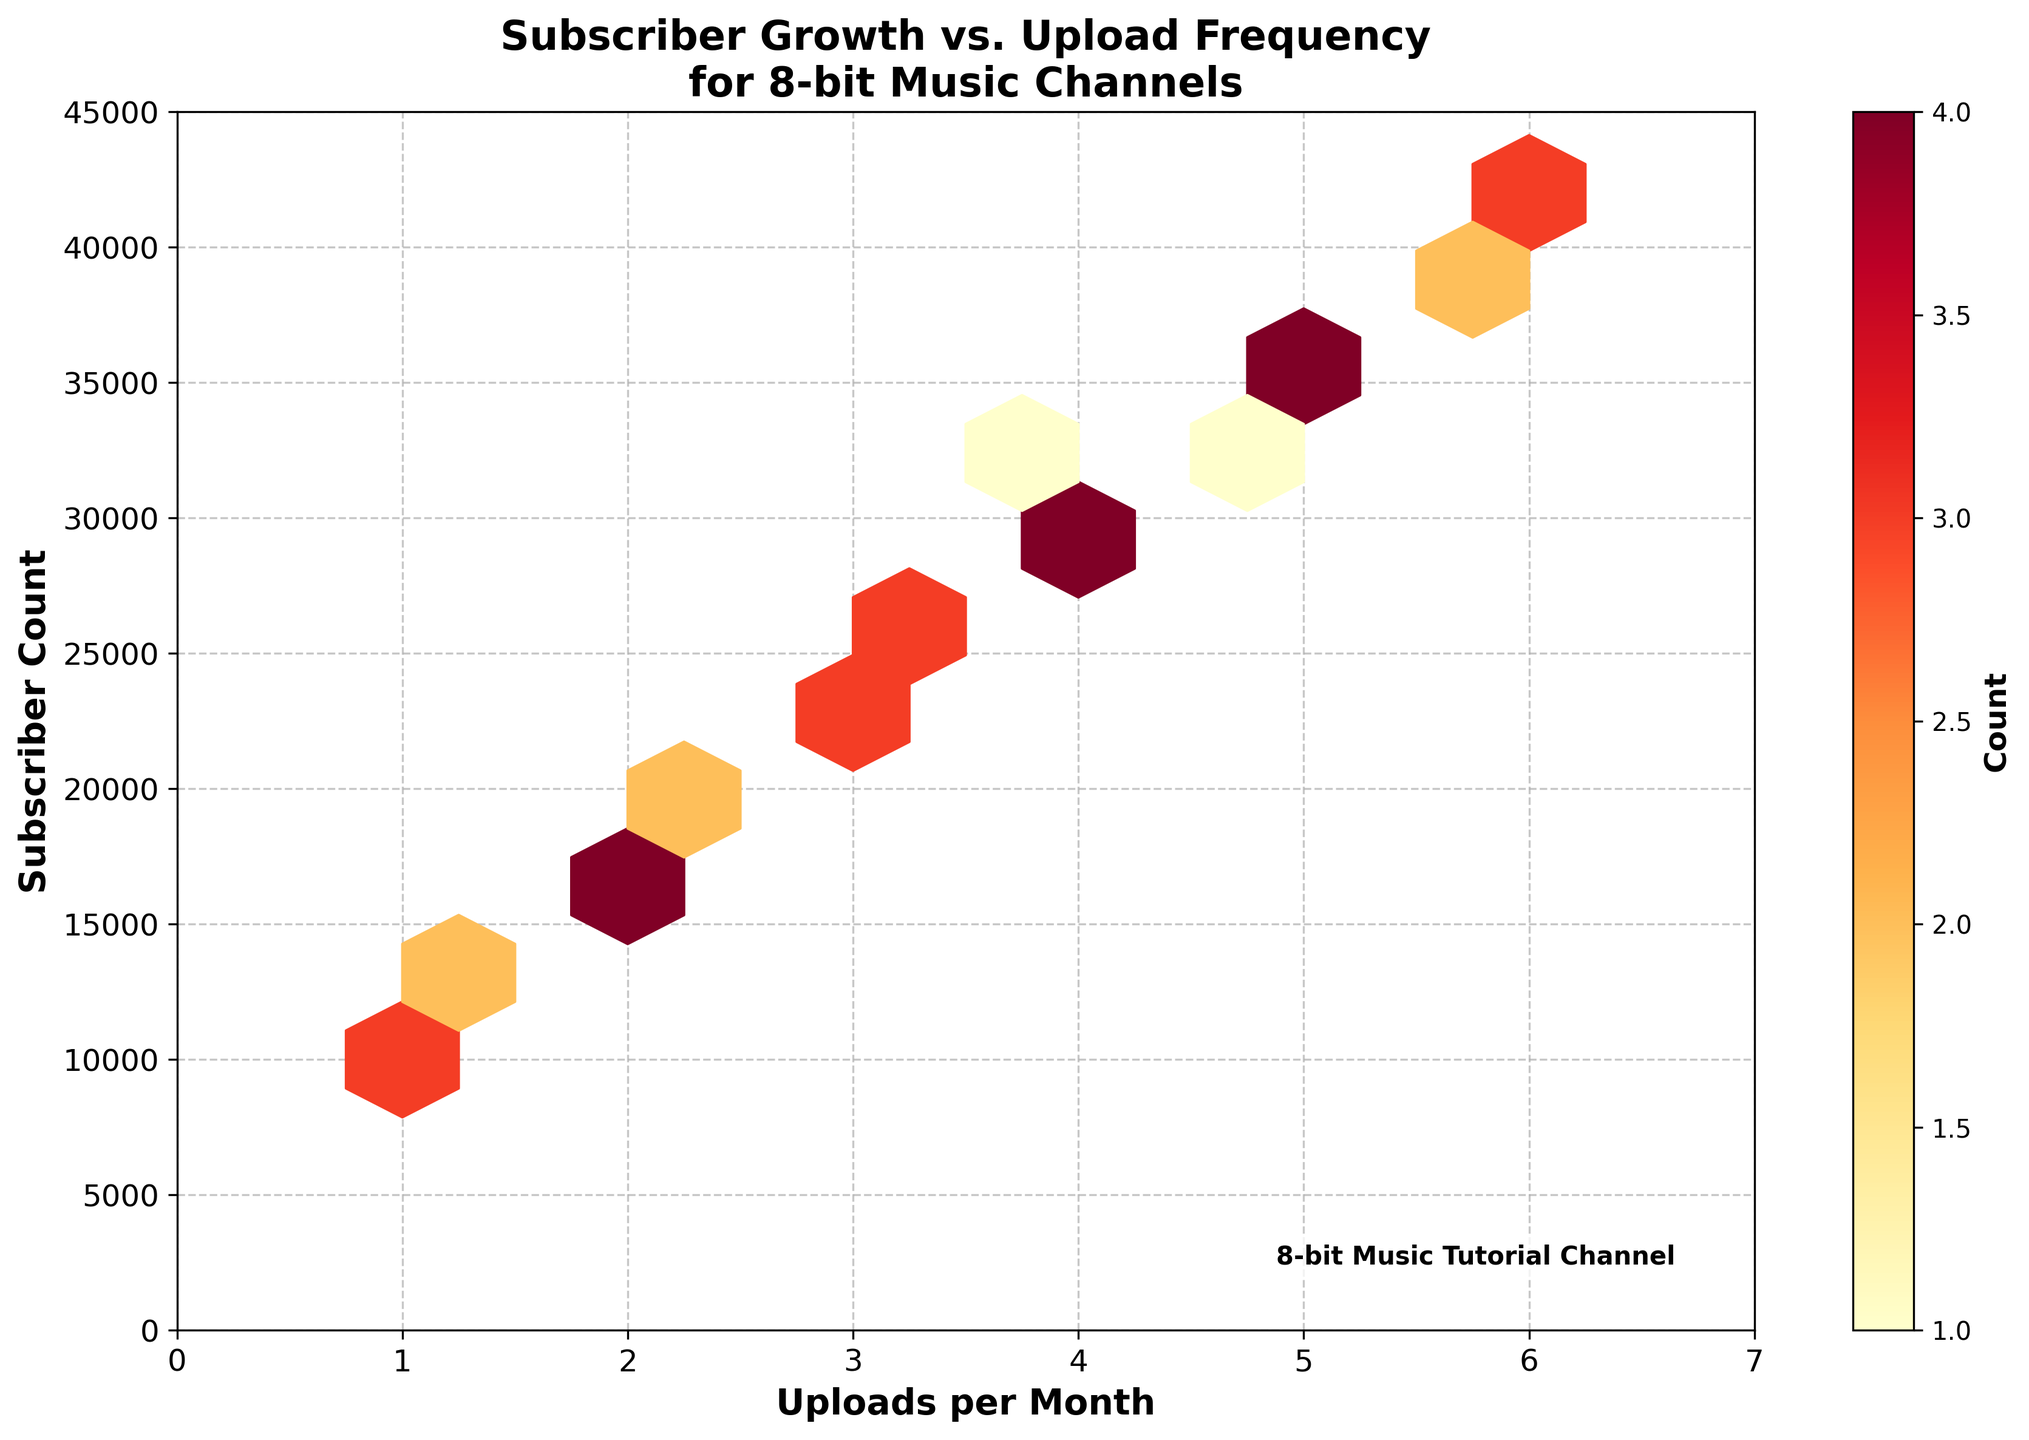What is the title of the plot? The title of the plot is presented at the top, describing what the figure represents: 'Subscriber Growth vs. Upload Frequency for 8-bit Music Channels'.
Answer: Subscriber Growth vs. Upload Frequency for 8-bit Music Channels What are the variables on the x-axis and y-axis? The x-axis and y-axis labels are shown near the axes. The x-axis is labeled 'Uploads per Month', and the y-axis is labeled 'Subscriber Count'.
Answer: Uploads per Month; Subscriber Count How many color bins are there in the hexbin plot? The figure uses different shades of yellow, orange, and red to show density. By observing the color legend, there are three major color bins: yellow, orange, and red. However, exact colors within these ranges might vary, making it difficult to count precisely, but the main groups can be visually identified.
Answer: 3 main color bins Which upload frequency range has the highest concentration of higher subscriber count (darker colored hexagons)? The darkest colored hexagons, which indicate the highest concentration of data points, are located in the upload frequency range of 5 to 6 uploads per month. These are in the top right section of the plot.
Answer: 5 to 6 uploads per month What is the approximate range of subscriber counts for channels that upload 3 times per month? By looking at the vertical range of hexagons aligned with '3' on the x-axis, the subscriber counts appear to range approximately from 20,000 to 27,000.
Answer: 20,000 to 27,000 Is there a positive or negative correlation between uploads per month and subscriber count? Observing the hexbin pattern trending from lower left (fewer uploads and lower subscriber count) to upper right (more uploads and higher subscriber count) suggests a positive correlation.
Answer: Positive correlation What does the color bar represent in the plot? The color bar on the side of the plot indicates the count of data points in each hexbin. Darker colors correspond to higher counts.
Answer: Count of data points Which upload frequency ranges show the least number of data points (lightest colored hexagons)? The lightest hexagons, which indicate the least number of data points, are found at the ends of the x-axis (1 upload per month and 6 uploads per month range).
Answer: 1 and 6 uploads per month Approximately how many data points fall into the hexbin with the highest concentration (darkest color)? The color bar indicates that the count for the darkest hexagons is around 3 to possibly a few more. The exact count is given on the bar itself, corresponding to the darkest color on the plot.
Answer: Around 3 Do channels that upload only once a month achieve high subscriber counts? Observing the leftmost hexagons aligned with '1' on the x-axis, their corresponding subscriber counts do not go above 15,000, indicating low to moderate subscriber counts.
Answer: No 